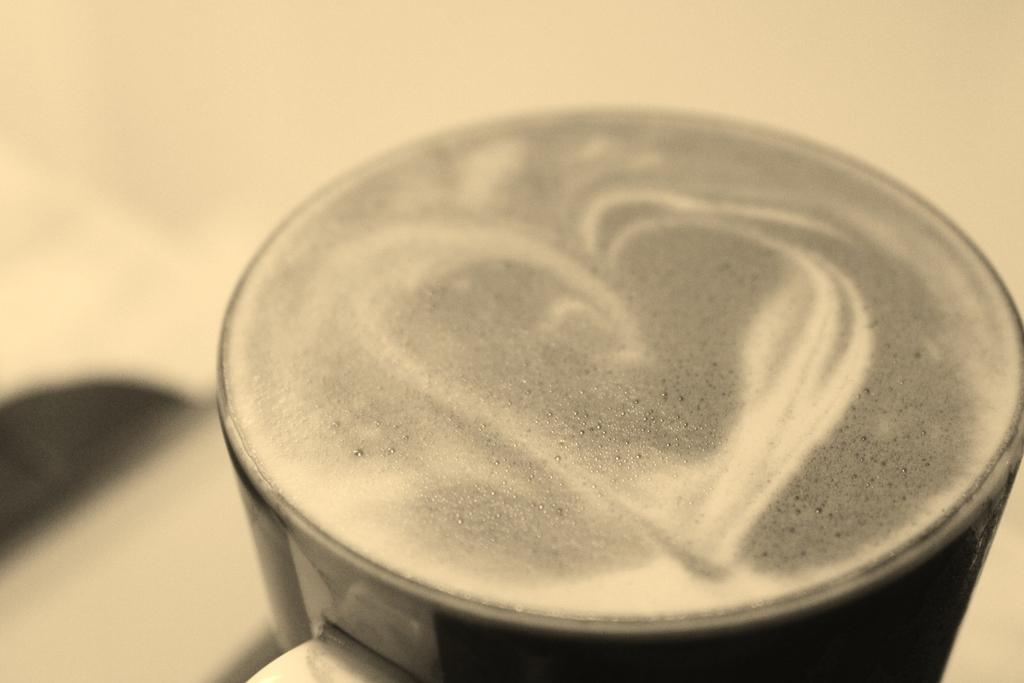What is the main subject of the image? The main subject of the image is a drink. How is the drink being served? The drink is served in a cup. What type of control panel can be seen in the image? There is no control panel present in the image; it features a drink served in a cup. How many eggs are visible in the image? There are no eggs present in the image. 